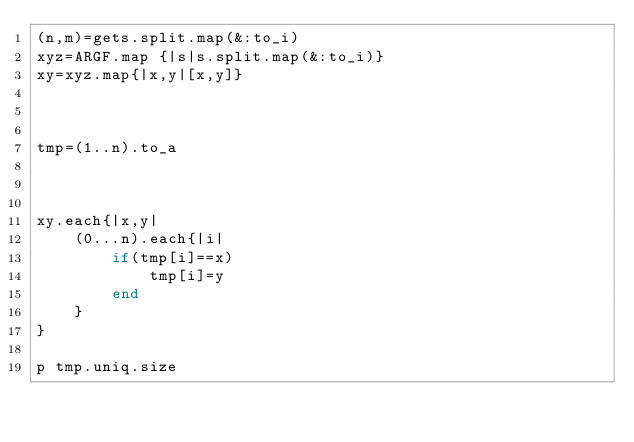<code> <loc_0><loc_0><loc_500><loc_500><_Ruby_>(n,m)=gets.split.map(&:to_i)
xyz=ARGF.map {|s|s.split.map(&:to_i)}
xy=xyz.map{|x,y|[x,y]}



tmp=(1..n).to_a



xy.each{|x,y|
    (0...n).each{|i|
        if(tmp[i]==x)
            tmp[i]=y
        end
    }
}

p tmp.uniq.size


</code> 